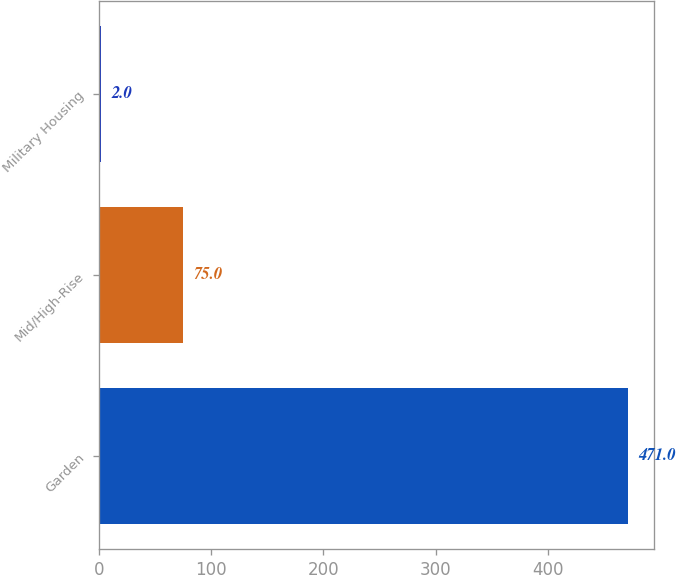Convert chart. <chart><loc_0><loc_0><loc_500><loc_500><bar_chart><fcel>Garden<fcel>Mid/High-Rise<fcel>Military Housing<nl><fcel>471<fcel>75<fcel>2<nl></chart> 